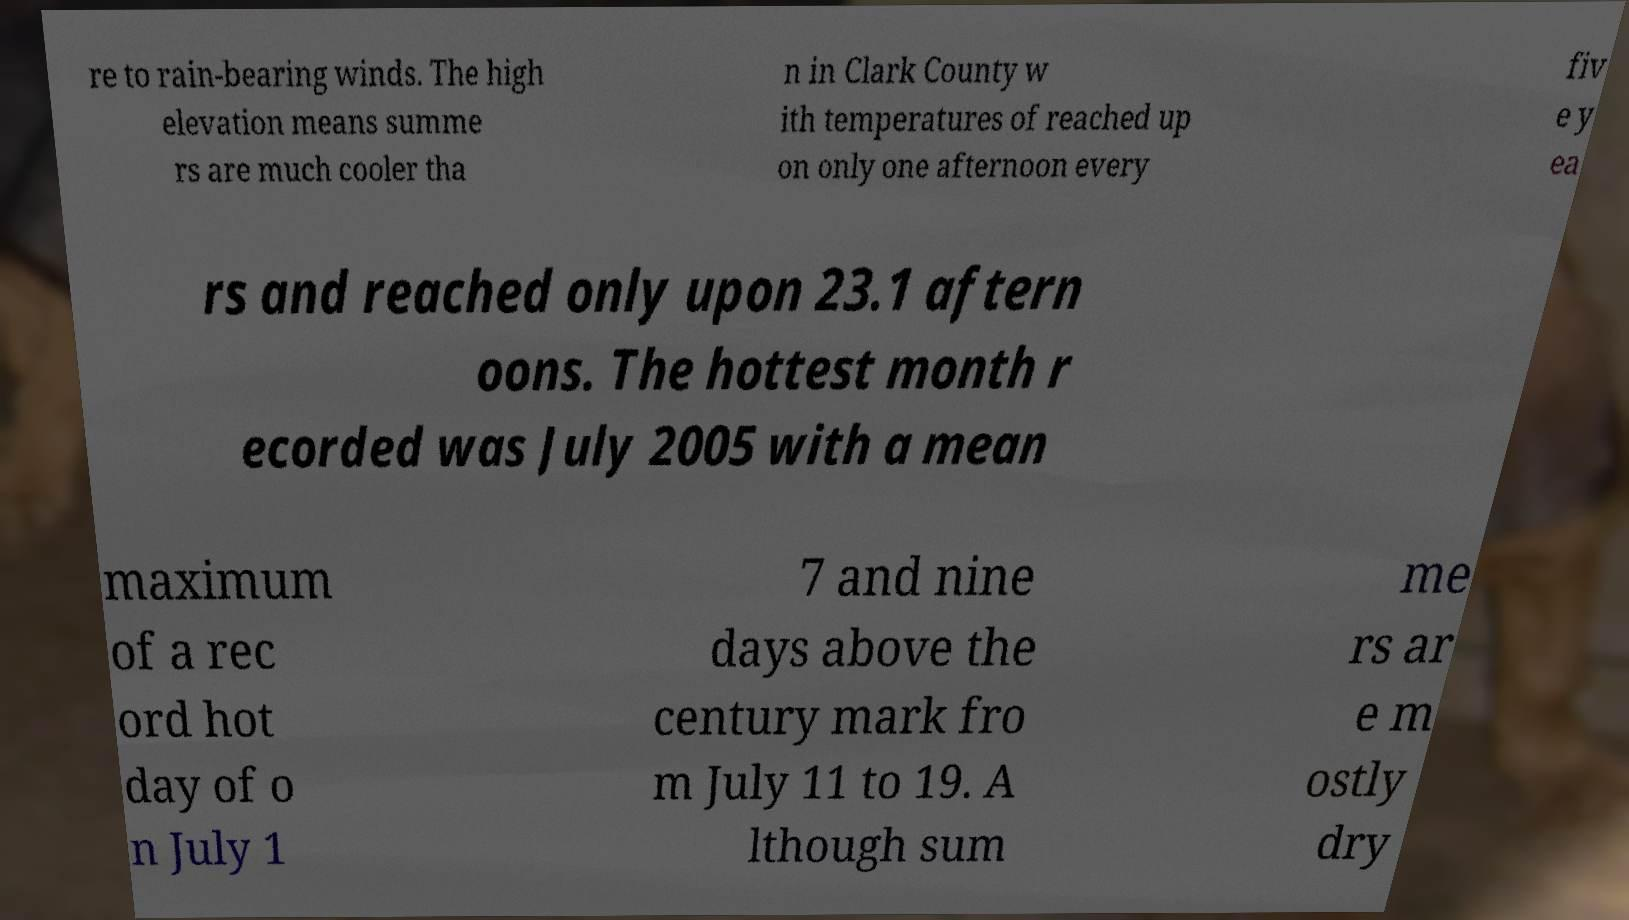Could you extract and type out the text from this image? re to rain-bearing winds. The high elevation means summe rs are much cooler tha n in Clark County w ith temperatures of reached up on only one afternoon every fiv e y ea rs and reached only upon 23.1 aftern oons. The hottest month r ecorded was July 2005 with a mean maximum of a rec ord hot day of o n July 1 7 and nine days above the century mark fro m July 11 to 19. A lthough sum me rs ar e m ostly dry 